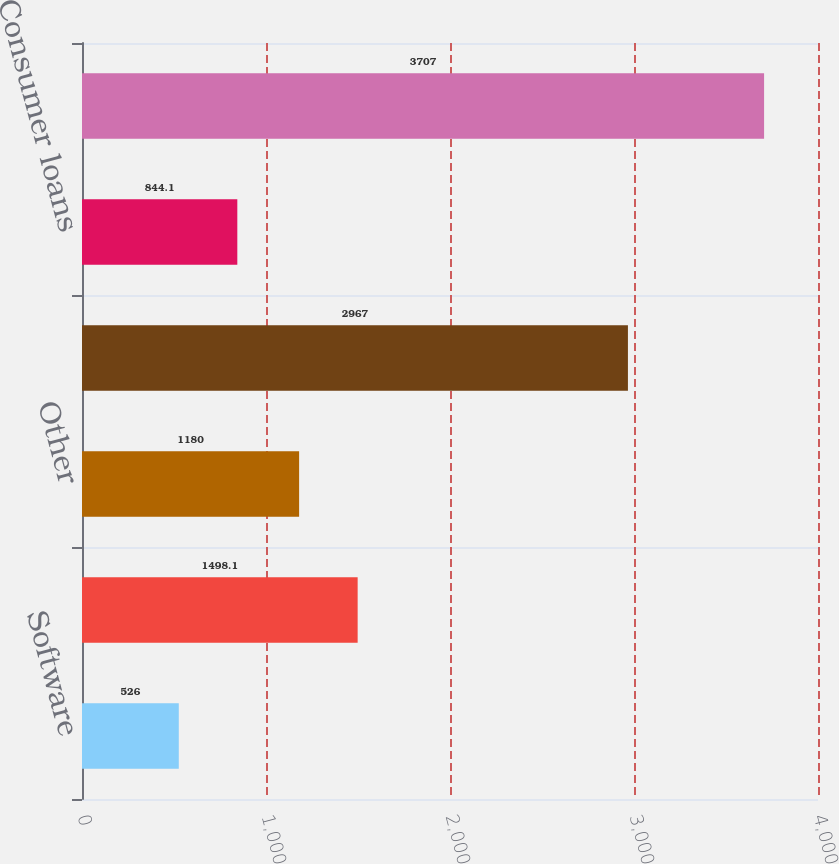Convert chart. <chart><loc_0><loc_0><loc_500><loc_500><bar_chart><fcel>Software<fcel>Hardware<fcel>Other<fcel>Total commercial loans<fcel>Consumer loans<fcel>Total allowance for loan<nl><fcel>526<fcel>1498.1<fcel>1180<fcel>2967<fcel>844.1<fcel>3707<nl></chart> 